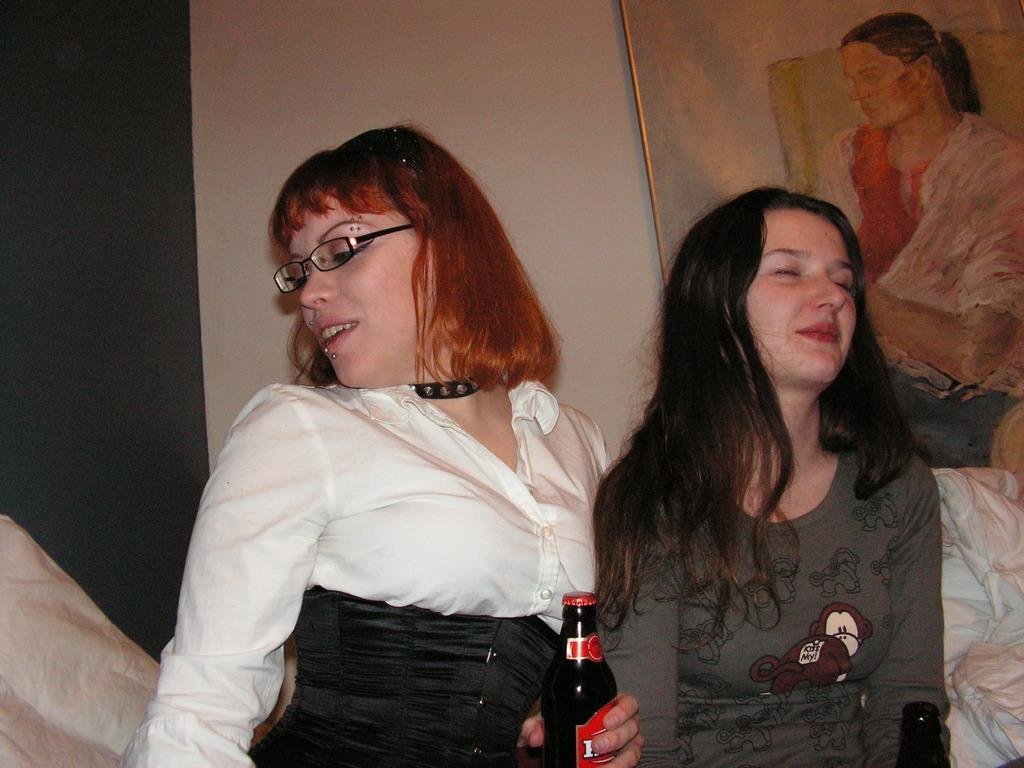How many people are in the image? There are two women in the image. What are the women holding in the image? The women are holding beer bottles. What are the women doing in the image? The women are sitting. What type of furniture is in the image? There is a couch in the image. What is attached to the wall in the image? There is a frame attached to the wall in the image. How many eggs are visible in the image? There are no eggs visible in the image. What type of range is present in the image? There is no range present in the image. 